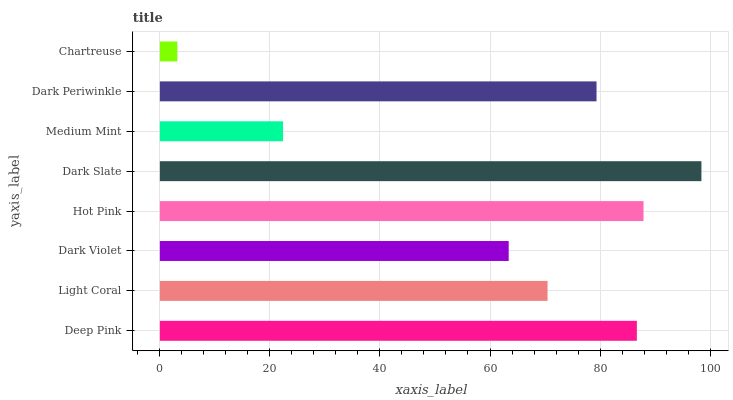Is Chartreuse the minimum?
Answer yes or no. Yes. Is Dark Slate the maximum?
Answer yes or no. Yes. Is Light Coral the minimum?
Answer yes or no. No. Is Light Coral the maximum?
Answer yes or no. No. Is Deep Pink greater than Light Coral?
Answer yes or no. Yes. Is Light Coral less than Deep Pink?
Answer yes or no. Yes. Is Light Coral greater than Deep Pink?
Answer yes or no. No. Is Deep Pink less than Light Coral?
Answer yes or no. No. Is Dark Periwinkle the high median?
Answer yes or no. Yes. Is Light Coral the low median?
Answer yes or no. Yes. Is Chartreuse the high median?
Answer yes or no. No. Is Dark Periwinkle the low median?
Answer yes or no. No. 